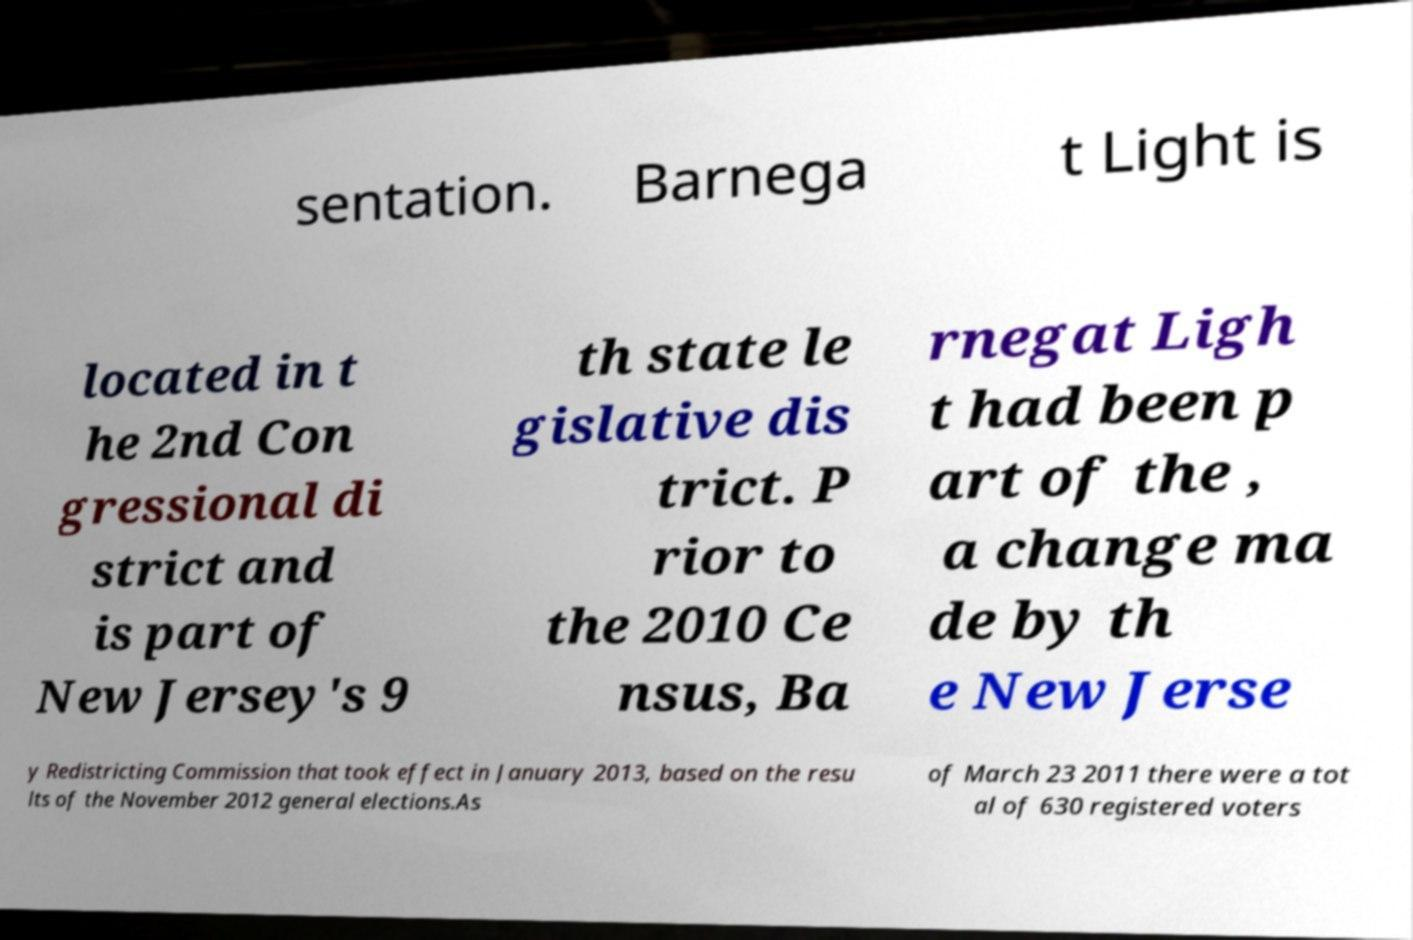Please read and relay the text visible in this image. What does it say? sentation. Barnega t Light is located in t he 2nd Con gressional di strict and is part of New Jersey's 9 th state le gislative dis trict. P rior to the 2010 Ce nsus, Ba rnegat Ligh t had been p art of the , a change ma de by th e New Jerse y Redistricting Commission that took effect in January 2013, based on the resu lts of the November 2012 general elections.As of March 23 2011 there were a tot al of 630 registered voters 